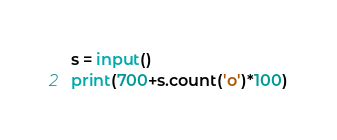Convert code to text. <code><loc_0><loc_0><loc_500><loc_500><_Python_>s = input()
print(700+s.count('o')*100)</code> 